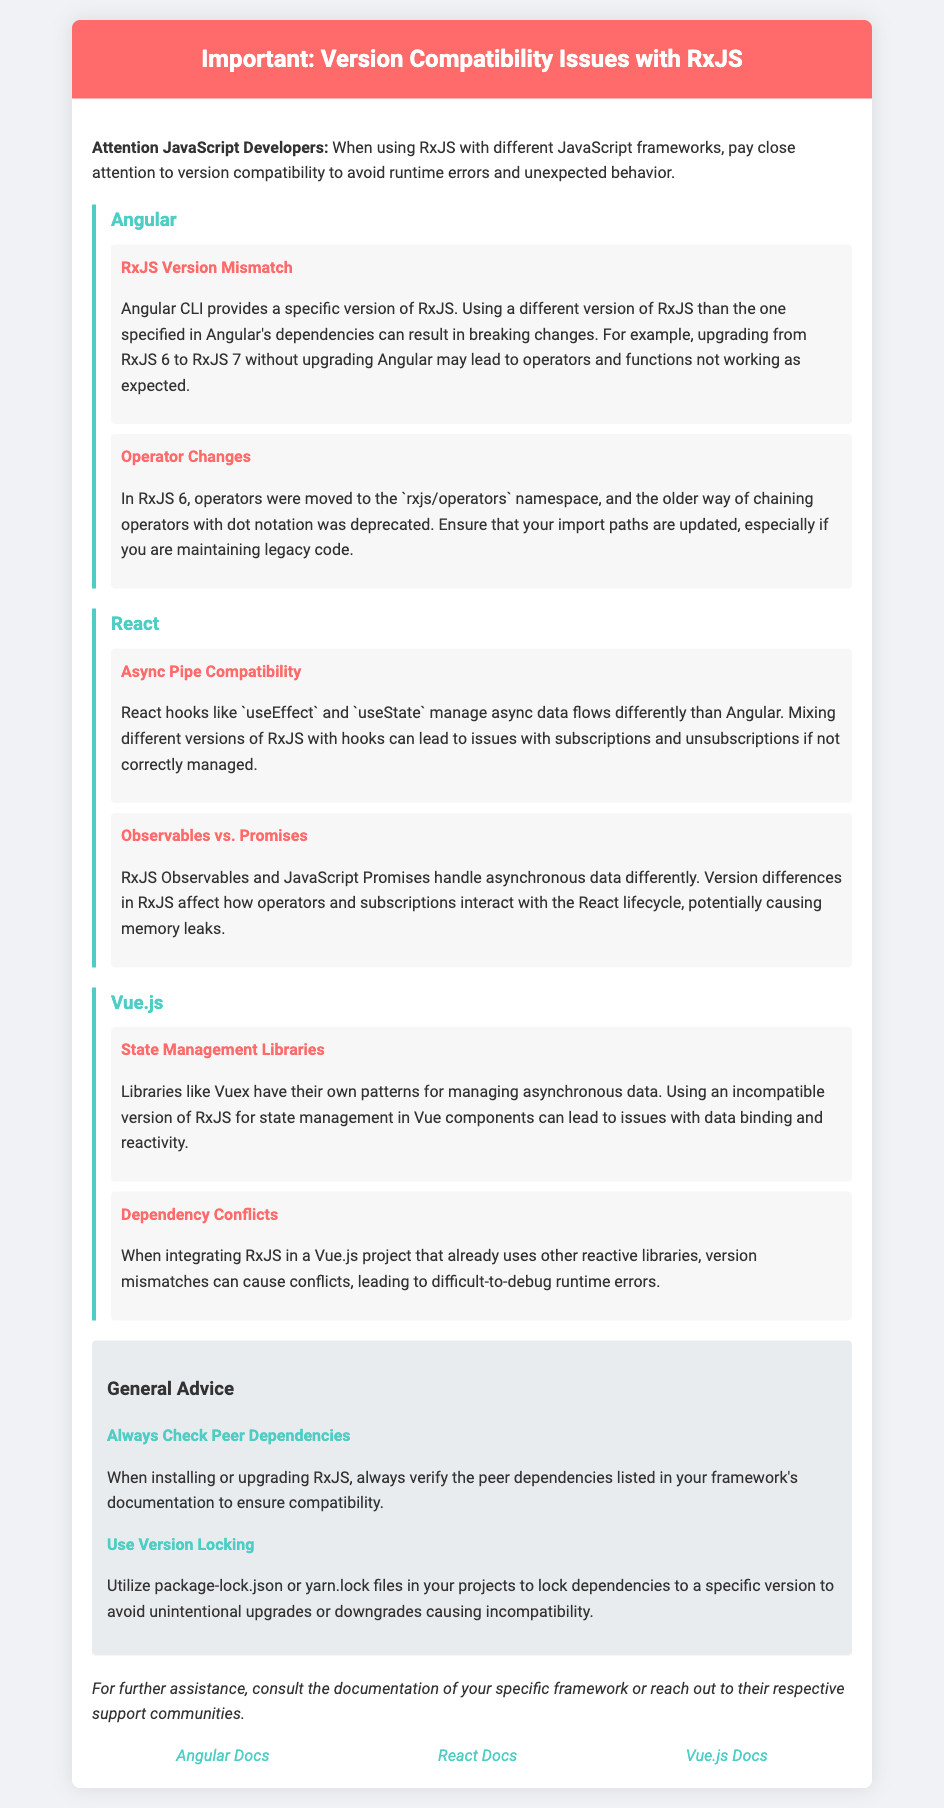What is the main topic of the document? The main topic is about compatibility issues regarding RxJS when used with different JavaScript frameworks.
Answer: Version Compatibility Issues with RxJS Which version of RxJS may cause issues in Angular? The document mentions that upgrading from RxJS 6 to RxJS 7 can lead to problems if Angular is not also upgraded.
Answer: RxJS 6 to RxJS 7 What does the document advise using to avoid unintentional upgrades? It suggests utilizing specific files that help lock dependencies, preventing versions from changing unintentionally.
Answer: package-lock.json or yarn.lock In which section would you find issues related to Vue.js? The section that addresses compatibility problems specific to Vue.js projects.
Answer: Vue.js What are subscribers potentially at risk of when mixing different versions of RxJS in React? The document specifically mentions a concern related to improper management.
Answer: Memory leaks What is Angular's specific advice for RxJS? The document mentions checking peer dependencies as a key step for ensuring compatibility.
Answer: Always Check Peer Dependencies How are operators handled differently in RxJS 6 compared to older versions? The document notes a change in how operators are imported in RxJS 6, compared to older versions.
Answer: Moved to the rxjs/operators namespace What can dependency conflicts in Vue.js cause? Dependency conflicts when using different versions of libraries can lead to significant difficulties within the application.
Answer: Difficult-to-debug runtime errors 